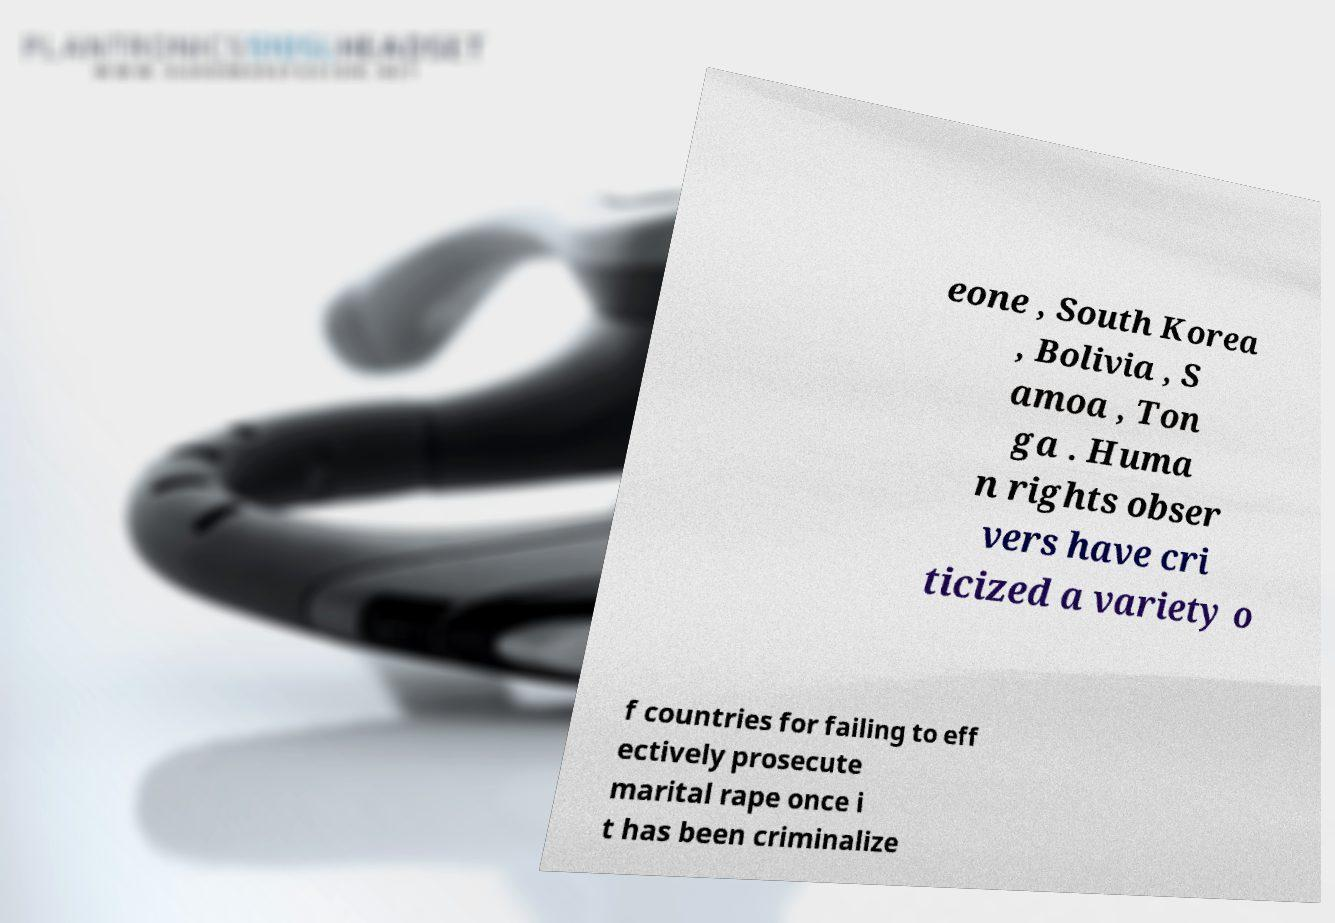Can you read and provide the text displayed in the image?This photo seems to have some interesting text. Can you extract and type it out for me? eone , South Korea , Bolivia , S amoa , Ton ga . Huma n rights obser vers have cri ticized a variety o f countries for failing to eff ectively prosecute marital rape once i t has been criminalize 